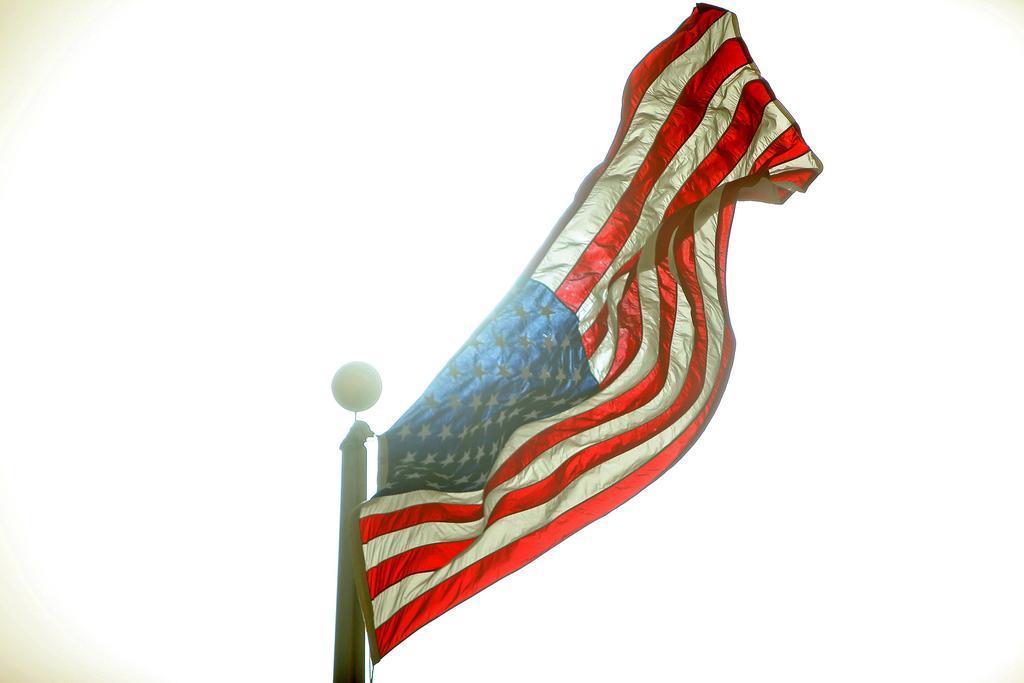Describe this image in one or two sentences. In this image I can see a flag and a pole. The background of the image is white in color. 